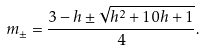<formula> <loc_0><loc_0><loc_500><loc_500>m _ { \pm } = \frac { 3 - h \pm \sqrt { h ^ { 2 } + 1 0 h + 1 } } { 4 } .</formula> 